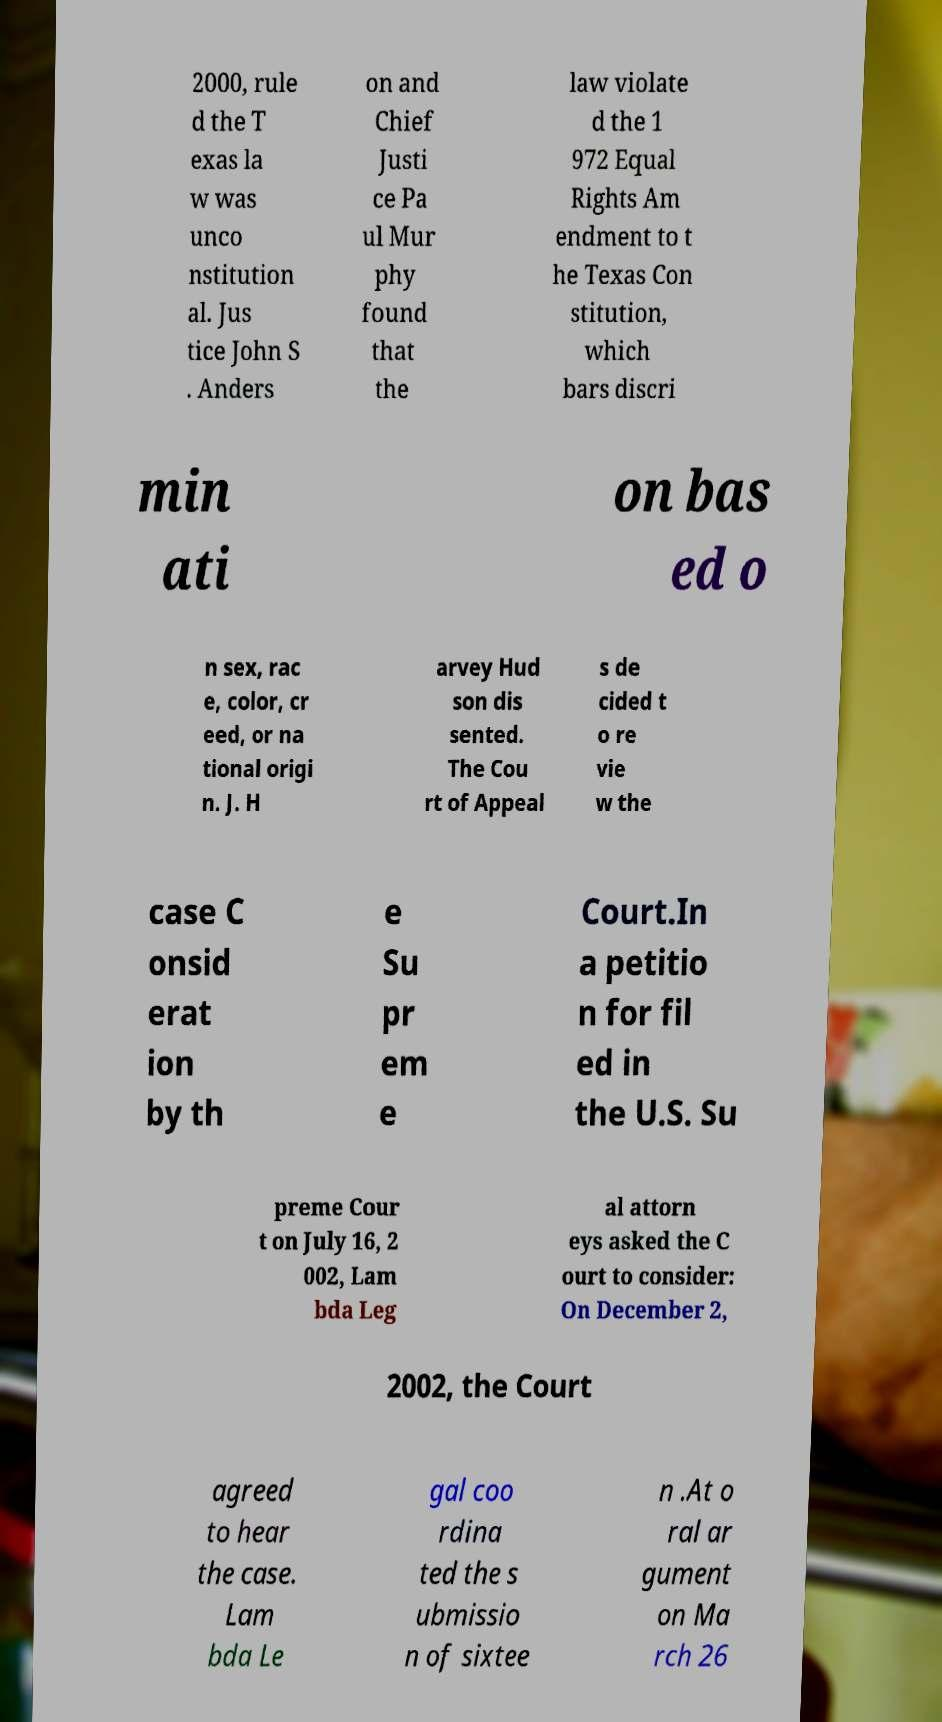Could you extract and type out the text from this image? 2000, rule d the T exas la w was unco nstitution al. Jus tice John S . Anders on and Chief Justi ce Pa ul Mur phy found that the law violate d the 1 972 Equal Rights Am endment to t he Texas Con stitution, which bars discri min ati on bas ed o n sex, rac e, color, cr eed, or na tional origi n. J. H arvey Hud son dis sented. The Cou rt of Appeal s de cided t o re vie w the case C onsid erat ion by th e Su pr em e Court.In a petitio n for fil ed in the U.S. Su preme Cour t on July 16, 2 002, Lam bda Leg al attorn eys asked the C ourt to consider: On December 2, 2002, the Court agreed to hear the case. Lam bda Le gal coo rdina ted the s ubmissio n of sixtee n .At o ral ar gument on Ma rch 26 